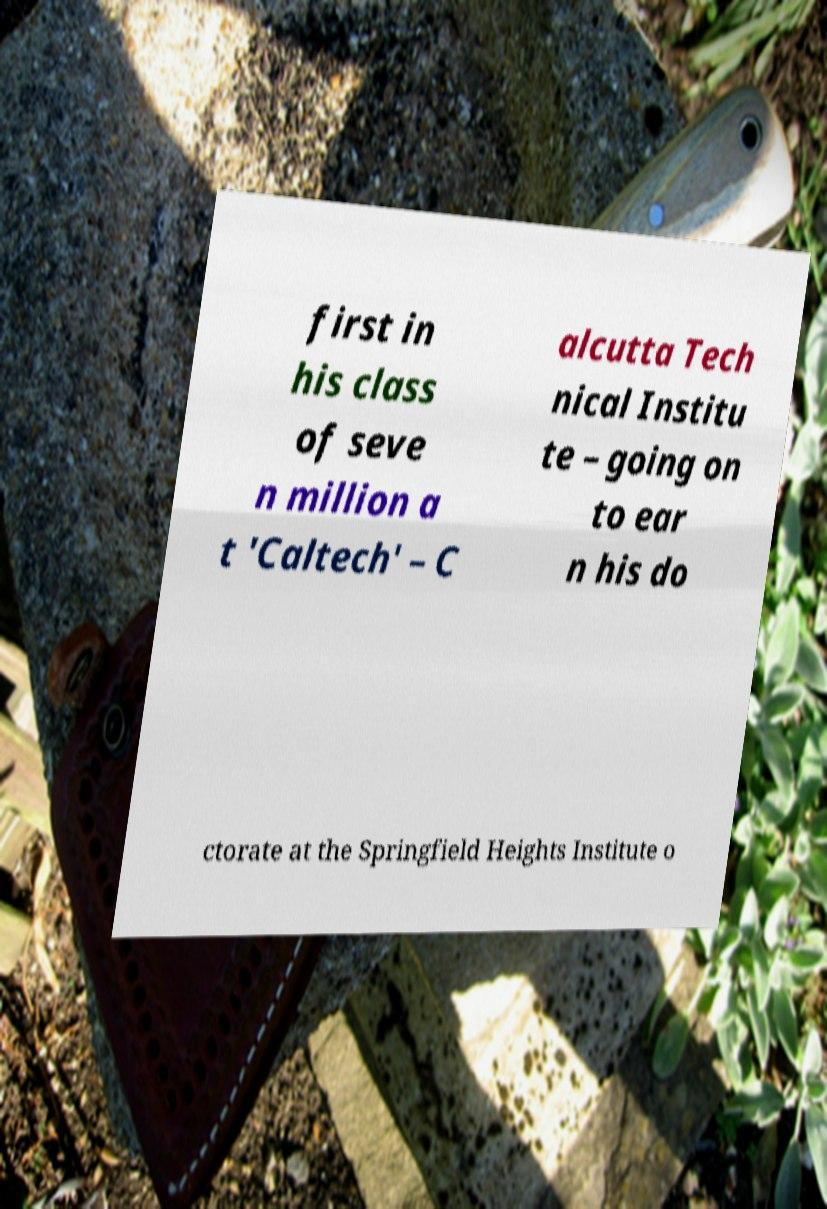Could you extract and type out the text from this image? first in his class of seve n million a t 'Caltech' – C alcutta Tech nical Institu te – going on to ear n his do ctorate at the Springfield Heights Institute o 